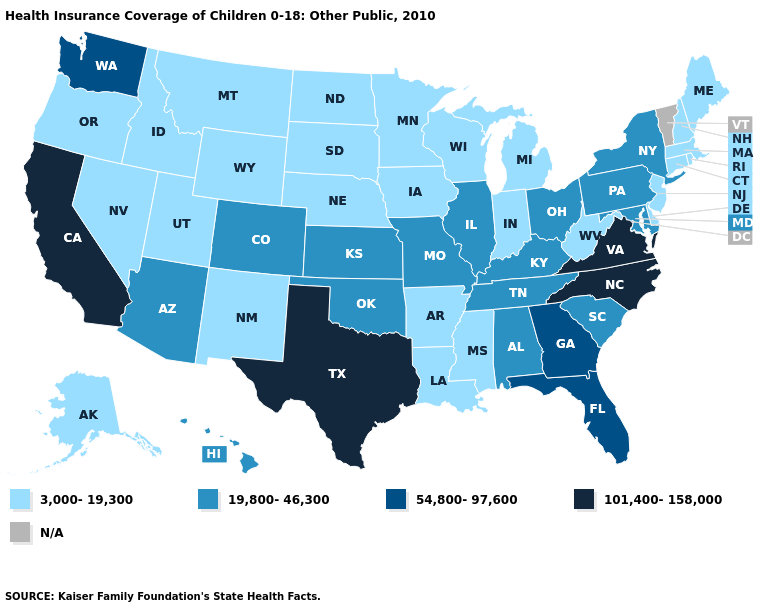What is the value of New Mexico?
Concise answer only. 3,000-19,300. Which states have the lowest value in the Northeast?
Be succinct. Connecticut, Maine, Massachusetts, New Hampshire, New Jersey, Rhode Island. Does the map have missing data?
Concise answer only. Yes. Name the states that have a value in the range 3,000-19,300?
Short answer required. Alaska, Arkansas, Connecticut, Delaware, Idaho, Indiana, Iowa, Louisiana, Maine, Massachusetts, Michigan, Minnesota, Mississippi, Montana, Nebraska, Nevada, New Hampshire, New Jersey, New Mexico, North Dakota, Oregon, Rhode Island, South Dakota, Utah, West Virginia, Wisconsin, Wyoming. Among the states that border New Jersey , which have the highest value?
Keep it brief. New York, Pennsylvania. What is the value of Tennessee?
Answer briefly. 19,800-46,300. What is the value of South Carolina?
Write a very short answer. 19,800-46,300. What is the lowest value in the West?
Answer briefly. 3,000-19,300. Does Ohio have the highest value in the MidWest?
Answer briefly. Yes. What is the value of North Dakota?
Give a very brief answer. 3,000-19,300. Name the states that have a value in the range 101,400-158,000?
Answer briefly. California, North Carolina, Texas, Virginia. What is the highest value in states that border Arkansas?
Write a very short answer. 101,400-158,000. Does the map have missing data?
Be succinct. Yes. 